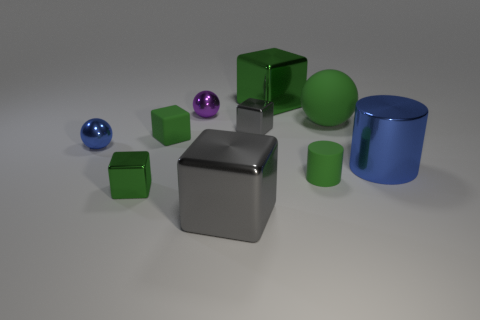Subtract all gray balls. How many green blocks are left? 3 Subtract all purple blocks. Subtract all cyan cylinders. How many blocks are left? 5 Subtract all balls. How many objects are left? 7 Subtract all small green rubber cubes. Subtract all big cylinders. How many objects are left? 8 Add 1 tiny shiny spheres. How many tiny shiny spheres are left? 3 Add 7 tiny green things. How many tiny green things exist? 10 Subtract 1 blue balls. How many objects are left? 9 